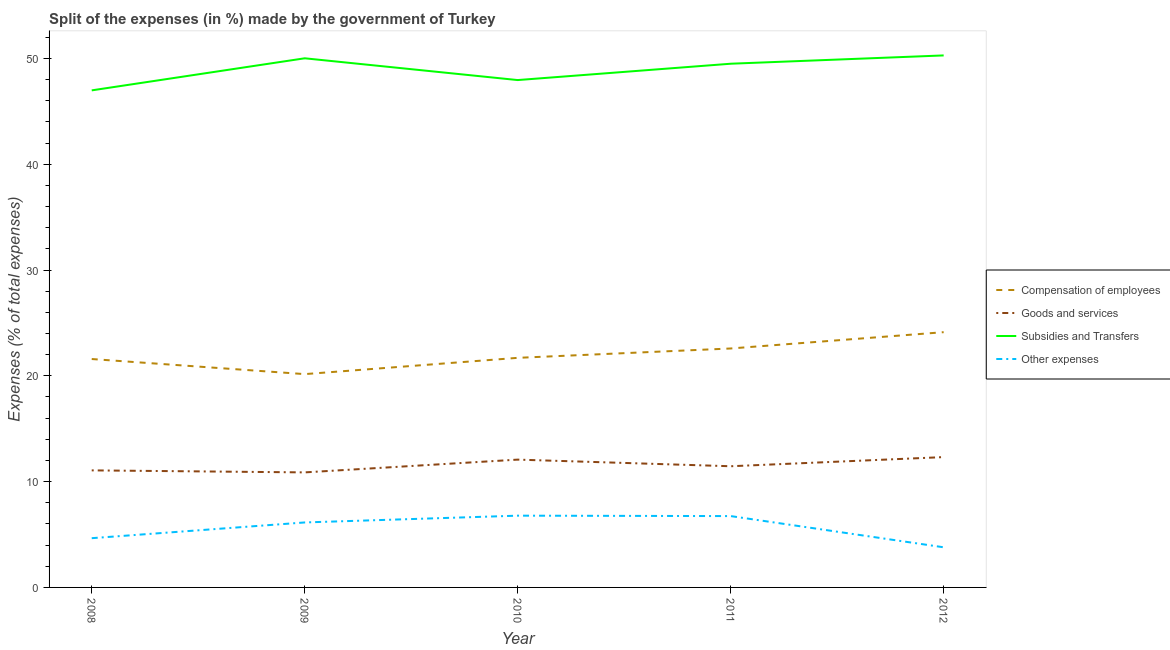Is the number of lines equal to the number of legend labels?
Ensure brevity in your answer.  Yes. What is the percentage of amount spent on compensation of employees in 2011?
Offer a terse response. 22.58. Across all years, what is the maximum percentage of amount spent on other expenses?
Give a very brief answer. 6.78. Across all years, what is the minimum percentage of amount spent on subsidies?
Your answer should be compact. 46.98. In which year was the percentage of amount spent on subsidies maximum?
Provide a short and direct response. 2012. In which year was the percentage of amount spent on compensation of employees minimum?
Keep it short and to the point. 2009. What is the total percentage of amount spent on compensation of employees in the graph?
Keep it short and to the point. 110.16. What is the difference between the percentage of amount spent on subsidies in 2009 and that in 2010?
Provide a succinct answer. 2.06. What is the difference between the percentage of amount spent on other expenses in 2011 and the percentage of amount spent on goods and services in 2012?
Give a very brief answer. -5.58. What is the average percentage of amount spent on compensation of employees per year?
Your response must be concise. 22.03. In the year 2008, what is the difference between the percentage of amount spent on other expenses and percentage of amount spent on compensation of employees?
Ensure brevity in your answer.  -16.93. What is the ratio of the percentage of amount spent on compensation of employees in 2008 to that in 2011?
Keep it short and to the point. 0.96. Is the difference between the percentage of amount spent on subsidies in 2008 and 2011 greater than the difference between the percentage of amount spent on goods and services in 2008 and 2011?
Offer a terse response. No. What is the difference between the highest and the second highest percentage of amount spent on subsidies?
Make the answer very short. 0.27. What is the difference between the highest and the lowest percentage of amount spent on goods and services?
Provide a short and direct response. 1.45. In how many years, is the percentage of amount spent on other expenses greater than the average percentage of amount spent on other expenses taken over all years?
Give a very brief answer. 3. Is it the case that in every year, the sum of the percentage of amount spent on compensation of employees and percentage of amount spent on goods and services is greater than the percentage of amount spent on subsidies?
Keep it short and to the point. No. How many lines are there?
Your answer should be compact. 4. How many years are there in the graph?
Provide a short and direct response. 5. Are the values on the major ticks of Y-axis written in scientific E-notation?
Make the answer very short. No. Does the graph contain any zero values?
Keep it short and to the point. No. Does the graph contain grids?
Your answer should be compact. No. Where does the legend appear in the graph?
Ensure brevity in your answer.  Center right. How many legend labels are there?
Your answer should be very brief. 4. How are the legend labels stacked?
Keep it short and to the point. Vertical. What is the title of the graph?
Ensure brevity in your answer.  Split of the expenses (in %) made by the government of Turkey. Does "Payroll services" appear as one of the legend labels in the graph?
Keep it short and to the point. No. What is the label or title of the Y-axis?
Ensure brevity in your answer.  Expenses (% of total expenses). What is the Expenses (% of total expenses) of Compensation of employees in 2008?
Your answer should be very brief. 21.59. What is the Expenses (% of total expenses) in Goods and services in 2008?
Give a very brief answer. 11.06. What is the Expenses (% of total expenses) in Subsidies and Transfers in 2008?
Your response must be concise. 46.98. What is the Expenses (% of total expenses) in Other expenses in 2008?
Make the answer very short. 4.65. What is the Expenses (% of total expenses) in Compensation of employees in 2009?
Offer a terse response. 20.16. What is the Expenses (% of total expenses) in Goods and services in 2009?
Ensure brevity in your answer.  10.87. What is the Expenses (% of total expenses) in Subsidies and Transfers in 2009?
Keep it short and to the point. 50.01. What is the Expenses (% of total expenses) in Other expenses in 2009?
Offer a very short reply. 6.14. What is the Expenses (% of total expenses) in Compensation of employees in 2010?
Provide a short and direct response. 21.7. What is the Expenses (% of total expenses) of Goods and services in 2010?
Provide a short and direct response. 12.08. What is the Expenses (% of total expenses) of Subsidies and Transfers in 2010?
Make the answer very short. 47.95. What is the Expenses (% of total expenses) in Other expenses in 2010?
Your answer should be compact. 6.78. What is the Expenses (% of total expenses) of Compensation of employees in 2011?
Your answer should be very brief. 22.58. What is the Expenses (% of total expenses) of Goods and services in 2011?
Your response must be concise. 11.45. What is the Expenses (% of total expenses) of Subsidies and Transfers in 2011?
Provide a short and direct response. 49.5. What is the Expenses (% of total expenses) of Other expenses in 2011?
Provide a short and direct response. 6.74. What is the Expenses (% of total expenses) of Compensation of employees in 2012?
Your answer should be very brief. 24.13. What is the Expenses (% of total expenses) of Goods and services in 2012?
Ensure brevity in your answer.  12.32. What is the Expenses (% of total expenses) of Subsidies and Transfers in 2012?
Provide a short and direct response. 50.28. What is the Expenses (% of total expenses) of Other expenses in 2012?
Your answer should be very brief. 3.79. Across all years, what is the maximum Expenses (% of total expenses) of Compensation of employees?
Keep it short and to the point. 24.13. Across all years, what is the maximum Expenses (% of total expenses) in Goods and services?
Provide a succinct answer. 12.32. Across all years, what is the maximum Expenses (% of total expenses) in Subsidies and Transfers?
Keep it short and to the point. 50.28. Across all years, what is the maximum Expenses (% of total expenses) in Other expenses?
Offer a terse response. 6.78. Across all years, what is the minimum Expenses (% of total expenses) in Compensation of employees?
Keep it short and to the point. 20.16. Across all years, what is the minimum Expenses (% of total expenses) in Goods and services?
Your answer should be very brief. 10.87. Across all years, what is the minimum Expenses (% of total expenses) of Subsidies and Transfers?
Your answer should be very brief. 46.98. Across all years, what is the minimum Expenses (% of total expenses) in Other expenses?
Provide a succinct answer. 3.79. What is the total Expenses (% of total expenses) of Compensation of employees in the graph?
Your answer should be compact. 110.16. What is the total Expenses (% of total expenses) in Goods and services in the graph?
Give a very brief answer. 57.79. What is the total Expenses (% of total expenses) of Subsidies and Transfers in the graph?
Provide a succinct answer. 244.73. What is the total Expenses (% of total expenses) in Other expenses in the graph?
Ensure brevity in your answer.  28.11. What is the difference between the Expenses (% of total expenses) of Compensation of employees in 2008 and that in 2009?
Provide a succinct answer. 1.43. What is the difference between the Expenses (% of total expenses) of Goods and services in 2008 and that in 2009?
Your answer should be compact. 0.19. What is the difference between the Expenses (% of total expenses) in Subsidies and Transfers in 2008 and that in 2009?
Give a very brief answer. -3.03. What is the difference between the Expenses (% of total expenses) in Other expenses in 2008 and that in 2009?
Keep it short and to the point. -1.49. What is the difference between the Expenses (% of total expenses) in Compensation of employees in 2008 and that in 2010?
Your answer should be very brief. -0.11. What is the difference between the Expenses (% of total expenses) of Goods and services in 2008 and that in 2010?
Offer a terse response. -1.02. What is the difference between the Expenses (% of total expenses) in Subsidies and Transfers in 2008 and that in 2010?
Provide a short and direct response. -0.97. What is the difference between the Expenses (% of total expenses) of Other expenses in 2008 and that in 2010?
Your response must be concise. -2.13. What is the difference between the Expenses (% of total expenses) in Compensation of employees in 2008 and that in 2011?
Offer a very short reply. -1. What is the difference between the Expenses (% of total expenses) of Goods and services in 2008 and that in 2011?
Ensure brevity in your answer.  -0.39. What is the difference between the Expenses (% of total expenses) in Subsidies and Transfers in 2008 and that in 2011?
Your answer should be very brief. -2.52. What is the difference between the Expenses (% of total expenses) in Other expenses in 2008 and that in 2011?
Your answer should be compact. -2.09. What is the difference between the Expenses (% of total expenses) in Compensation of employees in 2008 and that in 2012?
Make the answer very short. -2.54. What is the difference between the Expenses (% of total expenses) in Goods and services in 2008 and that in 2012?
Provide a succinct answer. -1.25. What is the difference between the Expenses (% of total expenses) of Subsidies and Transfers in 2008 and that in 2012?
Your answer should be compact. -3.3. What is the difference between the Expenses (% of total expenses) of Other expenses in 2008 and that in 2012?
Your response must be concise. 0.86. What is the difference between the Expenses (% of total expenses) in Compensation of employees in 2009 and that in 2010?
Provide a short and direct response. -1.54. What is the difference between the Expenses (% of total expenses) in Goods and services in 2009 and that in 2010?
Provide a short and direct response. -1.21. What is the difference between the Expenses (% of total expenses) of Subsidies and Transfers in 2009 and that in 2010?
Your answer should be very brief. 2.06. What is the difference between the Expenses (% of total expenses) of Other expenses in 2009 and that in 2010?
Your response must be concise. -0.64. What is the difference between the Expenses (% of total expenses) in Compensation of employees in 2009 and that in 2011?
Ensure brevity in your answer.  -2.42. What is the difference between the Expenses (% of total expenses) of Goods and services in 2009 and that in 2011?
Your answer should be very brief. -0.58. What is the difference between the Expenses (% of total expenses) in Subsidies and Transfers in 2009 and that in 2011?
Offer a very short reply. 0.51. What is the difference between the Expenses (% of total expenses) in Other expenses in 2009 and that in 2011?
Offer a terse response. -0.6. What is the difference between the Expenses (% of total expenses) of Compensation of employees in 2009 and that in 2012?
Make the answer very short. -3.96. What is the difference between the Expenses (% of total expenses) of Goods and services in 2009 and that in 2012?
Offer a very short reply. -1.45. What is the difference between the Expenses (% of total expenses) in Subsidies and Transfers in 2009 and that in 2012?
Your answer should be compact. -0.27. What is the difference between the Expenses (% of total expenses) in Other expenses in 2009 and that in 2012?
Keep it short and to the point. 2.35. What is the difference between the Expenses (% of total expenses) in Compensation of employees in 2010 and that in 2011?
Provide a short and direct response. -0.88. What is the difference between the Expenses (% of total expenses) of Goods and services in 2010 and that in 2011?
Your answer should be compact. 0.63. What is the difference between the Expenses (% of total expenses) of Subsidies and Transfers in 2010 and that in 2011?
Give a very brief answer. -1.54. What is the difference between the Expenses (% of total expenses) in Other expenses in 2010 and that in 2011?
Provide a succinct answer. 0.04. What is the difference between the Expenses (% of total expenses) of Compensation of employees in 2010 and that in 2012?
Provide a short and direct response. -2.43. What is the difference between the Expenses (% of total expenses) in Goods and services in 2010 and that in 2012?
Your answer should be compact. -0.24. What is the difference between the Expenses (% of total expenses) of Subsidies and Transfers in 2010 and that in 2012?
Offer a very short reply. -2.33. What is the difference between the Expenses (% of total expenses) in Other expenses in 2010 and that in 2012?
Your response must be concise. 2.99. What is the difference between the Expenses (% of total expenses) of Compensation of employees in 2011 and that in 2012?
Keep it short and to the point. -1.54. What is the difference between the Expenses (% of total expenses) in Goods and services in 2011 and that in 2012?
Provide a short and direct response. -0.87. What is the difference between the Expenses (% of total expenses) in Subsidies and Transfers in 2011 and that in 2012?
Your answer should be very brief. -0.79. What is the difference between the Expenses (% of total expenses) in Other expenses in 2011 and that in 2012?
Your response must be concise. 2.95. What is the difference between the Expenses (% of total expenses) in Compensation of employees in 2008 and the Expenses (% of total expenses) in Goods and services in 2009?
Offer a terse response. 10.72. What is the difference between the Expenses (% of total expenses) of Compensation of employees in 2008 and the Expenses (% of total expenses) of Subsidies and Transfers in 2009?
Provide a succinct answer. -28.42. What is the difference between the Expenses (% of total expenses) of Compensation of employees in 2008 and the Expenses (% of total expenses) of Other expenses in 2009?
Provide a short and direct response. 15.45. What is the difference between the Expenses (% of total expenses) of Goods and services in 2008 and the Expenses (% of total expenses) of Subsidies and Transfers in 2009?
Your response must be concise. -38.95. What is the difference between the Expenses (% of total expenses) in Goods and services in 2008 and the Expenses (% of total expenses) in Other expenses in 2009?
Provide a succinct answer. 4.92. What is the difference between the Expenses (% of total expenses) of Subsidies and Transfers in 2008 and the Expenses (% of total expenses) of Other expenses in 2009?
Keep it short and to the point. 40.84. What is the difference between the Expenses (% of total expenses) in Compensation of employees in 2008 and the Expenses (% of total expenses) in Goods and services in 2010?
Offer a terse response. 9.51. What is the difference between the Expenses (% of total expenses) in Compensation of employees in 2008 and the Expenses (% of total expenses) in Subsidies and Transfers in 2010?
Your answer should be very brief. -26.37. What is the difference between the Expenses (% of total expenses) in Compensation of employees in 2008 and the Expenses (% of total expenses) in Other expenses in 2010?
Provide a succinct answer. 14.8. What is the difference between the Expenses (% of total expenses) in Goods and services in 2008 and the Expenses (% of total expenses) in Subsidies and Transfers in 2010?
Your answer should be compact. -36.89. What is the difference between the Expenses (% of total expenses) of Goods and services in 2008 and the Expenses (% of total expenses) of Other expenses in 2010?
Your answer should be very brief. 4.28. What is the difference between the Expenses (% of total expenses) in Subsidies and Transfers in 2008 and the Expenses (% of total expenses) in Other expenses in 2010?
Offer a very short reply. 40.2. What is the difference between the Expenses (% of total expenses) of Compensation of employees in 2008 and the Expenses (% of total expenses) of Goods and services in 2011?
Provide a succinct answer. 10.13. What is the difference between the Expenses (% of total expenses) of Compensation of employees in 2008 and the Expenses (% of total expenses) of Subsidies and Transfers in 2011?
Provide a succinct answer. -27.91. What is the difference between the Expenses (% of total expenses) of Compensation of employees in 2008 and the Expenses (% of total expenses) of Other expenses in 2011?
Offer a very short reply. 14.84. What is the difference between the Expenses (% of total expenses) in Goods and services in 2008 and the Expenses (% of total expenses) in Subsidies and Transfers in 2011?
Your response must be concise. -38.43. What is the difference between the Expenses (% of total expenses) in Goods and services in 2008 and the Expenses (% of total expenses) in Other expenses in 2011?
Offer a very short reply. 4.32. What is the difference between the Expenses (% of total expenses) of Subsidies and Transfers in 2008 and the Expenses (% of total expenses) of Other expenses in 2011?
Your response must be concise. 40.24. What is the difference between the Expenses (% of total expenses) in Compensation of employees in 2008 and the Expenses (% of total expenses) in Goods and services in 2012?
Keep it short and to the point. 9.27. What is the difference between the Expenses (% of total expenses) of Compensation of employees in 2008 and the Expenses (% of total expenses) of Subsidies and Transfers in 2012?
Make the answer very short. -28.7. What is the difference between the Expenses (% of total expenses) in Compensation of employees in 2008 and the Expenses (% of total expenses) in Other expenses in 2012?
Offer a terse response. 17.79. What is the difference between the Expenses (% of total expenses) of Goods and services in 2008 and the Expenses (% of total expenses) of Subsidies and Transfers in 2012?
Your response must be concise. -39.22. What is the difference between the Expenses (% of total expenses) in Goods and services in 2008 and the Expenses (% of total expenses) in Other expenses in 2012?
Make the answer very short. 7.27. What is the difference between the Expenses (% of total expenses) in Subsidies and Transfers in 2008 and the Expenses (% of total expenses) in Other expenses in 2012?
Your answer should be very brief. 43.19. What is the difference between the Expenses (% of total expenses) in Compensation of employees in 2009 and the Expenses (% of total expenses) in Goods and services in 2010?
Keep it short and to the point. 8.08. What is the difference between the Expenses (% of total expenses) in Compensation of employees in 2009 and the Expenses (% of total expenses) in Subsidies and Transfers in 2010?
Provide a short and direct response. -27.79. What is the difference between the Expenses (% of total expenses) in Compensation of employees in 2009 and the Expenses (% of total expenses) in Other expenses in 2010?
Offer a terse response. 13.38. What is the difference between the Expenses (% of total expenses) of Goods and services in 2009 and the Expenses (% of total expenses) of Subsidies and Transfers in 2010?
Give a very brief answer. -37.08. What is the difference between the Expenses (% of total expenses) in Goods and services in 2009 and the Expenses (% of total expenses) in Other expenses in 2010?
Provide a short and direct response. 4.09. What is the difference between the Expenses (% of total expenses) in Subsidies and Transfers in 2009 and the Expenses (% of total expenses) in Other expenses in 2010?
Your answer should be compact. 43.23. What is the difference between the Expenses (% of total expenses) of Compensation of employees in 2009 and the Expenses (% of total expenses) of Goods and services in 2011?
Your response must be concise. 8.71. What is the difference between the Expenses (% of total expenses) in Compensation of employees in 2009 and the Expenses (% of total expenses) in Subsidies and Transfers in 2011?
Offer a terse response. -29.34. What is the difference between the Expenses (% of total expenses) in Compensation of employees in 2009 and the Expenses (% of total expenses) in Other expenses in 2011?
Your response must be concise. 13.42. What is the difference between the Expenses (% of total expenses) in Goods and services in 2009 and the Expenses (% of total expenses) in Subsidies and Transfers in 2011?
Provide a succinct answer. -38.63. What is the difference between the Expenses (% of total expenses) in Goods and services in 2009 and the Expenses (% of total expenses) in Other expenses in 2011?
Ensure brevity in your answer.  4.13. What is the difference between the Expenses (% of total expenses) of Subsidies and Transfers in 2009 and the Expenses (% of total expenses) of Other expenses in 2011?
Ensure brevity in your answer.  43.27. What is the difference between the Expenses (% of total expenses) in Compensation of employees in 2009 and the Expenses (% of total expenses) in Goods and services in 2012?
Ensure brevity in your answer.  7.84. What is the difference between the Expenses (% of total expenses) of Compensation of employees in 2009 and the Expenses (% of total expenses) of Subsidies and Transfers in 2012?
Your answer should be very brief. -30.12. What is the difference between the Expenses (% of total expenses) of Compensation of employees in 2009 and the Expenses (% of total expenses) of Other expenses in 2012?
Provide a short and direct response. 16.37. What is the difference between the Expenses (% of total expenses) in Goods and services in 2009 and the Expenses (% of total expenses) in Subsidies and Transfers in 2012?
Keep it short and to the point. -39.41. What is the difference between the Expenses (% of total expenses) of Goods and services in 2009 and the Expenses (% of total expenses) of Other expenses in 2012?
Keep it short and to the point. 7.08. What is the difference between the Expenses (% of total expenses) in Subsidies and Transfers in 2009 and the Expenses (% of total expenses) in Other expenses in 2012?
Your response must be concise. 46.22. What is the difference between the Expenses (% of total expenses) in Compensation of employees in 2010 and the Expenses (% of total expenses) in Goods and services in 2011?
Provide a succinct answer. 10.25. What is the difference between the Expenses (% of total expenses) in Compensation of employees in 2010 and the Expenses (% of total expenses) in Subsidies and Transfers in 2011?
Give a very brief answer. -27.8. What is the difference between the Expenses (% of total expenses) in Compensation of employees in 2010 and the Expenses (% of total expenses) in Other expenses in 2011?
Make the answer very short. 14.96. What is the difference between the Expenses (% of total expenses) in Goods and services in 2010 and the Expenses (% of total expenses) in Subsidies and Transfers in 2011?
Make the answer very short. -37.42. What is the difference between the Expenses (% of total expenses) of Goods and services in 2010 and the Expenses (% of total expenses) of Other expenses in 2011?
Your response must be concise. 5.34. What is the difference between the Expenses (% of total expenses) in Subsidies and Transfers in 2010 and the Expenses (% of total expenses) in Other expenses in 2011?
Provide a succinct answer. 41.21. What is the difference between the Expenses (% of total expenses) in Compensation of employees in 2010 and the Expenses (% of total expenses) in Goods and services in 2012?
Your response must be concise. 9.38. What is the difference between the Expenses (% of total expenses) in Compensation of employees in 2010 and the Expenses (% of total expenses) in Subsidies and Transfers in 2012?
Provide a succinct answer. -28.58. What is the difference between the Expenses (% of total expenses) of Compensation of employees in 2010 and the Expenses (% of total expenses) of Other expenses in 2012?
Make the answer very short. 17.91. What is the difference between the Expenses (% of total expenses) of Goods and services in 2010 and the Expenses (% of total expenses) of Subsidies and Transfers in 2012?
Keep it short and to the point. -38.2. What is the difference between the Expenses (% of total expenses) of Goods and services in 2010 and the Expenses (% of total expenses) of Other expenses in 2012?
Offer a very short reply. 8.29. What is the difference between the Expenses (% of total expenses) of Subsidies and Transfers in 2010 and the Expenses (% of total expenses) of Other expenses in 2012?
Ensure brevity in your answer.  44.16. What is the difference between the Expenses (% of total expenses) in Compensation of employees in 2011 and the Expenses (% of total expenses) in Goods and services in 2012?
Keep it short and to the point. 10.27. What is the difference between the Expenses (% of total expenses) of Compensation of employees in 2011 and the Expenses (% of total expenses) of Subsidies and Transfers in 2012?
Your answer should be very brief. -27.7. What is the difference between the Expenses (% of total expenses) in Compensation of employees in 2011 and the Expenses (% of total expenses) in Other expenses in 2012?
Keep it short and to the point. 18.79. What is the difference between the Expenses (% of total expenses) of Goods and services in 2011 and the Expenses (% of total expenses) of Subsidies and Transfers in 2012?
Ensure brevity in your answer.  -38.83. What is the difference between the Expenses (% of total expenses) of Goods and services in 2011 and the Expenses (% of total expenses) of Other expenses in 2012?
Your response must be concise. 7.66. What is the difference between the Expenses (% of total expenses) in Subsidies and Transfers in 2011 and the Expenses (% of total expenses) in Other expenses in 2012?
Offer a terse response. 45.7. What is the average Expenses (% of total expenses) in Compensation of employees per year?
Provide a succinct answer. 22.03. What is the average Expenses (% of total expenses) in Goods and services per year?
Keep it short and to the point. 11.56. What is the average Expenses (% of total expenses) of Subsidies and Transfers per year?
Your answer should be very brief. 48.95. What is the average Expenses (% of total expenses) in Other expenses per year?
Give a very brief answer. 5.62. In the year 2008, what is the difference between the Expenses (% of total expenses) in Compensation of employees and Expenses (% of total expenses) in Goods and services?
Give a very brief answer. 10.52. In the year 2008, what is the difference between the Expenses (% of total expenses) in Compensation of employees and Expenses (% of total expenses) in Subsidies and Transfers?
Give a very brief answer. -25.39. In the year 2008, what is the difference between the Expenses (% of total expenses) of Compensation of employees and Expenses (% of total expenses) of Other expenses?
Keep it short and to the point. 16.93. In the year 2008, what is the difference between the Expenses (% of total expenses) in Goods and services and Expenses (% of total expenses) in Subsidies and Transfers?
Your answer should be compact. -35.92. In the year 2008, what is the difference between the Expenses (% of total expenses) in Goods and services and Expenses (% of total expenses) in Other expenses?
Your answer should be very brief. 6.41. In the year 2008, what is the difference between the Expenses (% of total expenses) in Subsidies and Transfers and Expenses (% of total expenses) in Other expenses?
Provide a short and direct response. 42.33. In the year 2009, what is the difference between the Expenses (% of total expenses) in Compensation of employees and Expenses (% of total expenses) in Goods and services?
Provide a short and direct response. 9.29. In the year 2009, what is the difference between the Expenses (% of total expenses) in Compensation of employees and Expenses (% of total expenses) in Subsidies and Transfers?
Ensure brevity in your answer.  -29.85. In the year 2009, what is the difference between the Expenses (% of total expenses) in Compensation of employees and Expenses (% of total expenses) in Other expenses?
Provide a succinct answer. 14.02. In the year 2009, what is the difference between the Expenses (% of total expenses) in Goods and services and Expenses (% of total expenses) in Subsidies and Transfers?
Provide a succinct answer. -39.14. In the year 2009, what is the difference between the Expenses (% of total expenses) of Goods and services and Expenses (% of total expenses) of Other expenses?
Ensure brevity in your answer.  4.73. In the year 2009, what is the difference between the Expenses (% of total expenses) of Subsidies and Transfers and Expenses (% of total expenses) of Other expenses?
Your answer should be very brief. 43.87. In the year 2010, what is the difference between the Expenses (% of total expenses) of Compensation of employees and Expenses (% of total expenses) of Goods and services?
Offer a terse response. 9.62. In the year 2010, what is the difference between the Expenses (% of total expenses) of Compensation of employees and Expenses (% of total expenses) of Subsidies and Transfers?
Ensure brevity in your answer.  -26.25. In the year 2010, what is the difference between the Expenses (% of total expenses) of Compensation of employees and Expenses (% of total expenses) of Other expenses?
Provide a short and direct response. 14.92. In the year 2010, what is the difference between the Expenses (% of total expenses) of Goods and services and Expenses (% of total expenses) of Subsidies and Transfers?
Ensure brevity in your answer.  -35.87. In the year 2010, what is the difference between the Expenses (% of total expenses) of Goods and services and Expenses (% of total expenses) of Other expenses?
Make the answer very short. 5.3. In the year 2010, what is the difference between the Expenses (% of total expenses) of Subsidies and Transfers and Expenses (% of total expenses) of Other expenses?
Offer a terse response. 41.17. In the year 2011, what is the difference between the Expenses (% of total expenses) in Compensation of employees and Expenses (% of total expenses) in Goods and services?
Give a very brief answer. 11.13. In the year 2011, what is the difference between the Expenses (% of total expenses) in Compensation of employees and Expenses (% of total expenses) in Subsidies and Transfers?
Your response must be concise. -26.91. In the year 2011, what is the difference between the Expenses (% of total expenses) of Compensation of employees and Expenses (% of total expenses) of Other expenses?
Your answer should be very brief. 15.84. In the year 2011, what is the difference between the Expenses (% of total expenses) of Goods and services and Expenses (% of total expenses) of Subsidies and Transfers?
Your response must be concise. -38.04. In the year 2011, what is the difference between the Expenses (% of total expenses) of Goods and services and Expenses (% of total expenses) of Other expenses?
Offer a very short reply. 4.71. In the year 2011, what is the difference between the Expenses (% of total expenses) in Subsidies and Transfers and Expenses (% of total expenses) in Other expenses?
Offer a very short reply. 42.76. In the year 2012, what is the difference between the Expenses (% of total expenses) in Compensation of employees and Expenses (% of total expenses) in Goods and services?
Keep it short and to the point. 11.81. In the year 2012, what is the difference between the Expenses (% of total expenses) in Compensation of employees and Expenses (% of total expenses) in Subsidies and Transfers?
Your response must be concise. -26.16. In the year 2012, what is the difference between the Expenses (% of total expenses) of Compensation of employees and Expenses (% of total expenses) of Other expenses?
Your answer should be very brief. 20.33. In the year 2012, what is the difference between the Expenses (% of total expenses) in Goods and services and Expenses (% of total expenses) in Subsidies and Transfers?
Provide a succinct answer. -37.96. In the year 2012, what is the difference between the Expenses (% of total expenses) in Goods and services and Expenses (% of total expenses) in Other expenses?
Ensure brevity in your answer.  8.53. In the year 2012, what is the difference between the Expenses (% of total expenses) in Subsidies and Transfers and Expenses (% of total expenses) in Other expenses?
Ensure brevity in your answer.  46.49. What is the ratio of the Expenses (% of total expenses) in Compensation of employees in 2008 to that in 2009?
Ensure brevity in your answer.  1.07. What is the ratio of the Expenses (% of total expenses) of Goods and services in 2008 to that in 2009?
Keep it short and to the point. 1.02. What is the ratio of the Expenses (% of total expenses) in Subsidies and Transfers in 2008 to that in 2009?
Give a very brief answer. 0.94. What is the ratio of the Expenses (% of total expenses) in Other expenses in 2008 to that in 2009?
Keep it short and to the point. 0.76. What is the ratio of the Expenses (% of total expenses) in Compensation of employees in 2008 to that in 2010?
Keep it short and to the point. 0.99. What is the ratio of the Expenses (% of total expenses) in Goods and services in 2008 to that in 2010?
Ensure brevity in your answer.  0.92. What is the ratio of the Expenses (% of total expenses) of Subsidies and Transfers in 2008 to that in 2010?
Your answer should be very brief. 0.98. What is the ratio of the Expenses (% of total expenses) of Other expenses in 2008 to that in 2010?
Keep it short and to the point. 0.69. What is the ratio of the Expenses (% of total expenses) of Compensation of employees in 2008 to that in 2011?
Ensure brevity in your answer.  0.96. What is the ratio of the Expenses (% of total expenses) of Subsidies and Transfers in 2008 to that in 2011?
Your answer should be compact. 0.95. What is the ratio of the Expenses (% of total expenses) in Other expenses in 2008 to that in 2011?
Your answer should be compact. 0.69. What is the ratio of the Expenses (% of total expenses) of Compensation of employees in 2008 to that in 2012?
Your answer should be compact. 0.89. What is the ratio of the Expenses (% of total expenses) of Goods and services in 2008 to that in 2012?
Your response must be concise. 0.9. What is the ratio of the Expenses (% of total expenses) in Subsidies and Transfers in 2008 to that in 2012?
Keep it short and to the point. 0.93. What is the ratio of the Expenses (% of total expenses) in Other expenses in 2008 to that in 2012?
Your answer should be compact. 1.23. What is the ratio of the Expenses (% of total expenses) in Compensation of employees in 2009 to that in 2010?
Offer a terse response. 0.93. What is the ratio of the Expenses (% of total expenses) in Goods and services in 2009 to that in 2010?
Offer a terse response. 0.9. What is the ratio of the Expenses (% of total expenses) of Subsidies and Transfers in 2009 to that in 2010?
Offer a very short reply. 1.04. What is the ratio of the Expenses (% of total expenses) of Other expenses in 2009 to that in 2010?
Give a very brief answer. 0.91. What is the ratio of the Expenses (% of total expenses) of Compensation of employees in 2009 to that in 2011?
Ensure brevity in your answer.  0.89. What is the ratio of the Expenses (% of total expenses) in Goods and services in 2009 to that in 2011?
Your answer should be compact. 0.95. What is the ratio of the Expenses (% of total expenses) of Subsidies and Transfers in 2009 to that in 2011?
Give a very brief answer. 1.01. What is the ratio of the Expenses (% of total expenses) of Other expenses in 2009 to that in 2011?
Give a very brief answer. 0.91. What is the ratio of the Expenses (% of total expenses) in Compensation of employees in 2009 to that in 2012?
Your answer should be compact. 0.84. What is the ratio of the Expenses (% of total expenses) of Goods and services in 2009 to that in 2012?
Your response must be concise. 0.88. What is the ratio of the Expenses (% of total expenses) in Subsidies and Transfers in 2009 to that in 2012?
Offer a very short reply. 0.99. What is the ratio of the Expenses (% of total expenses) of Other expenses in 2009 to that in 2012?
Offer a very short reply. 1.62. What is the ratio of the Expenses (% of total expenses) of Compensation of employees in 2010 to that in 2011?
Offer a terse response. 0.96. What is the ratio of the Expenses (% of total expenses) of Goods and services in 2010 to that in 2011?
Make the answer very short. 1.05. What is the ratio of the Expenses (% of total expenses) of Subsidies and Transfers in 2010 to that in 2011?
Make the answer very short. 0.97. What is the ratio of the Expenses (% of total expenses) of Other expenses in 2010 to that in 2011?
Provide a succinct answer. 1.01. What is the ratio of the Expenses (% of total expenses) in Compensation of employees in 2010 to that in 2012?
Ensure brevity in your answer.  0.9. What is the ratio of the Expenses (% of total expenses) in Goods and services in 2010 to that in 2012?
Make the answer very short. 0.98. What is the ratio of the Expenses (% of total expenses) of Subsidies and Transfers in 2010 to that in 2012?
Your answer should be very brief. 0.95. What is the ratio of the Expenses (% of total expenses) of Other expenses in 2010 to that in 2012?
Your response must be concise. 1.79. What is the ratio of the Expenses (% of total expenses) of Compensation of employees in 2011 to that in 2012?
Provide a short and direct response. 0.94. What is the ratio of the Expenses (% of total expenses) in Goods and services in 2011 to that in 2012?
Your response must be concise. 0.93. What is the ratio of the Expenses (% of total expenses) in Subsidies and Transfers in 2011 to that in 2012?
Provide a short and direct response. 0.98. What is the ratio of the Expenses (% of total expenses) in Other expenses in 2011 to that in 2012?
Offer a terse response. 1.78. What is the difference between the highest and the second highest Expenses (% of total expenses) in Compensation of employees?
Provide a succinct answer. 1.54. What is the difference between the highest and the second highest Expenses (% of total expenses) of Goods and services?
Give a very brief answer. 0.24. What is the difference between the highest and the second highest Expenses (% of total expenses) of Subsidies and Transfers?
Ensure brevity in your answer.  0.27. What is the difference between the highest and the second highest Expenses (% of total expenses) in Other expenses?
Your answer should be compact. 0.04. What is the difference between the highest and the lowest Expenses (% of total expenses) in Compensation of employees?
Make the answer very short. 3.96. What is the difference between the highest and the lowest Expenses (% of total expenses) in Goods and services?
Your response must be concise. 1.45. What is the difference between the highest and the lowest Expenses (% of total expenses) of Subsidies and Transfers?
Your answer should be compact. 3.3. What is the difference between the highest and the lowest Expenses (% of total expenses) in Other expenses?
Provide a short and direct response. 2.99. 